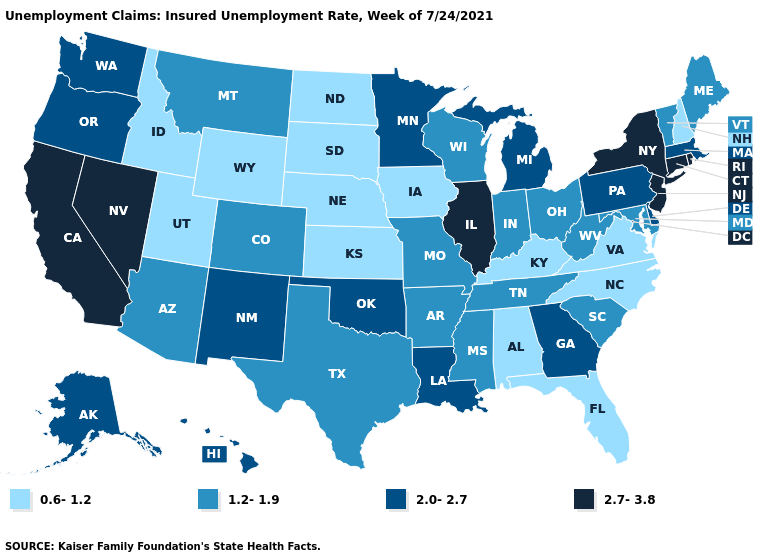Does Hawaii have the same value as Alaska?
Quick response, please. Yes. Name the states that have a value in the range 2.7-3.8?
Give a very brief answer. California, Connecticut, Illinois, Nevada, New Jersey, New York, Rhode Island. How many symbols are there in the legend?
Write a very short answer. 4. What is the value of Arizona?
Give a very brief answer. 1.2-1.9. What is the lowest value in states that border Washington?
Be succinct. 0.6-1.2. What is the lowest value in the Northeast?
Give a very brief answer. 0.6-1.2. What is the value of New York?
Concise answer only. 2.7-3.8. Name the states that have a value in the range 1.2-1.9?
Answer briefly. Arizona, Arkansas, Colorado, Indiana, Maine, Maryland, Mississippi, Missouri, Montana, Ohio, South Carolina, Tennessee, Texas, Vermont, West Virginia, Wisconsin. Name the states that have a value in the range 2.0-2.7?
Quick response, please. Alaska, Delaware, Georgia, Hawaii, Louisiana, Massachusetts, Michigan, Minnesota, New Mexico, Oklahoma, Oregon, Pennsylvania, Washington. Does Mississippi have the lowest value in the USA?
Quick response, please. No. Does Illinois have the highest value in the MidWest?
Be succinct. Yes. What is the lowest value in the West?
Write a very short answer. 0.6-1.2. What is the value of Montana?
Be succinct. 1.2-1.9. Does Idaho have the lowest value in the USA?
Keep it brief. Yes. How many symbols are there in the legend?
Keep it brief. 4. 